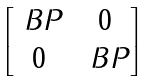<formula> <loc_0><loc_0><loc_500><loc_500>\begin{bmatrix} \ B P & 0 \\ 0 & \ B P \end{bmatrix}</formula> 